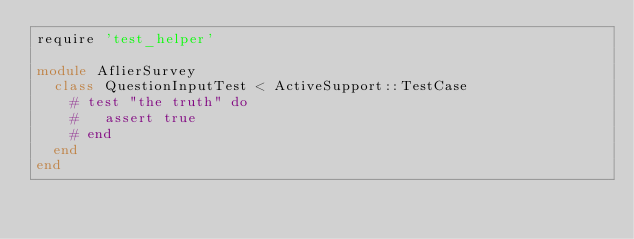<code> <loc_0><loc_0><loc_500><loc_500><_Ruby_>require 'test_helper'

module AflierSurvey
  class QuestionInputTest < ActiveSupport::TestCase
    # test "the truth" do
    #   assert true
    # end
  end
end
</code> 